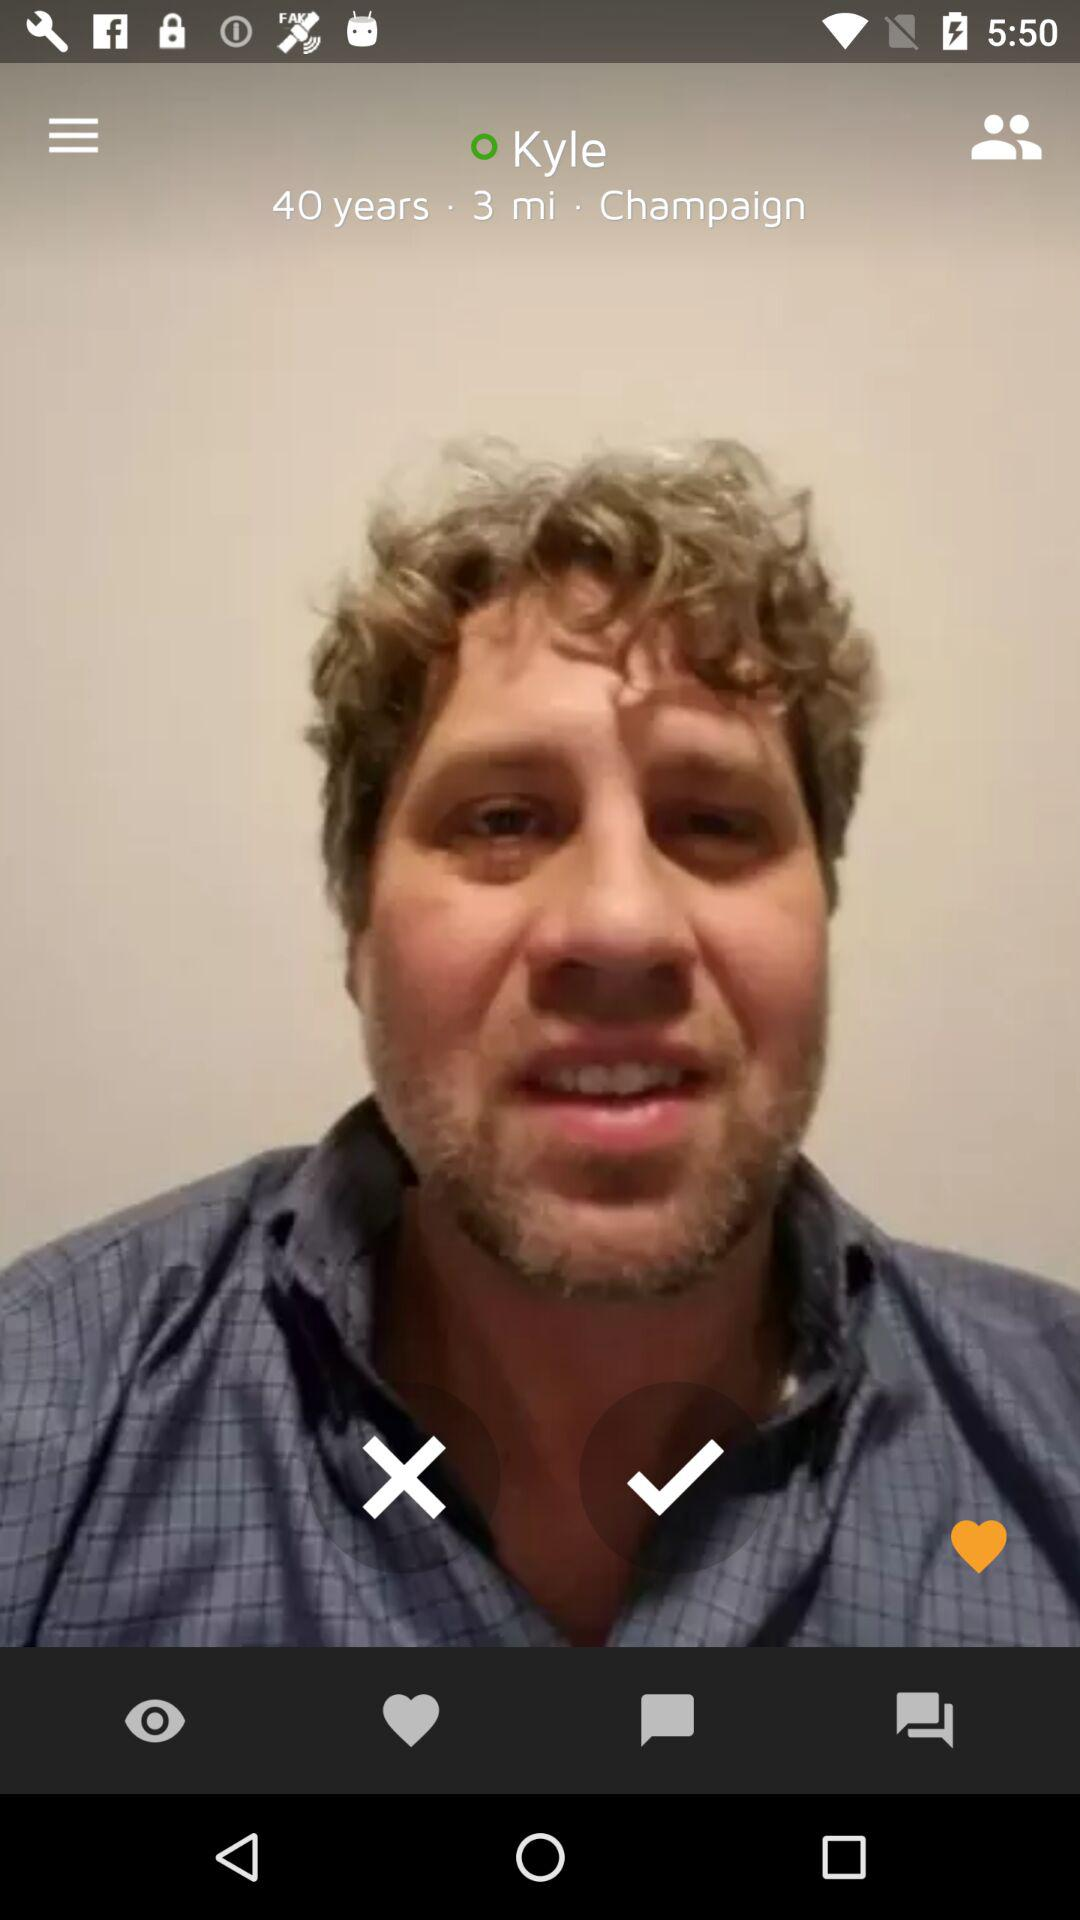What is the name? The name is Kyle. 